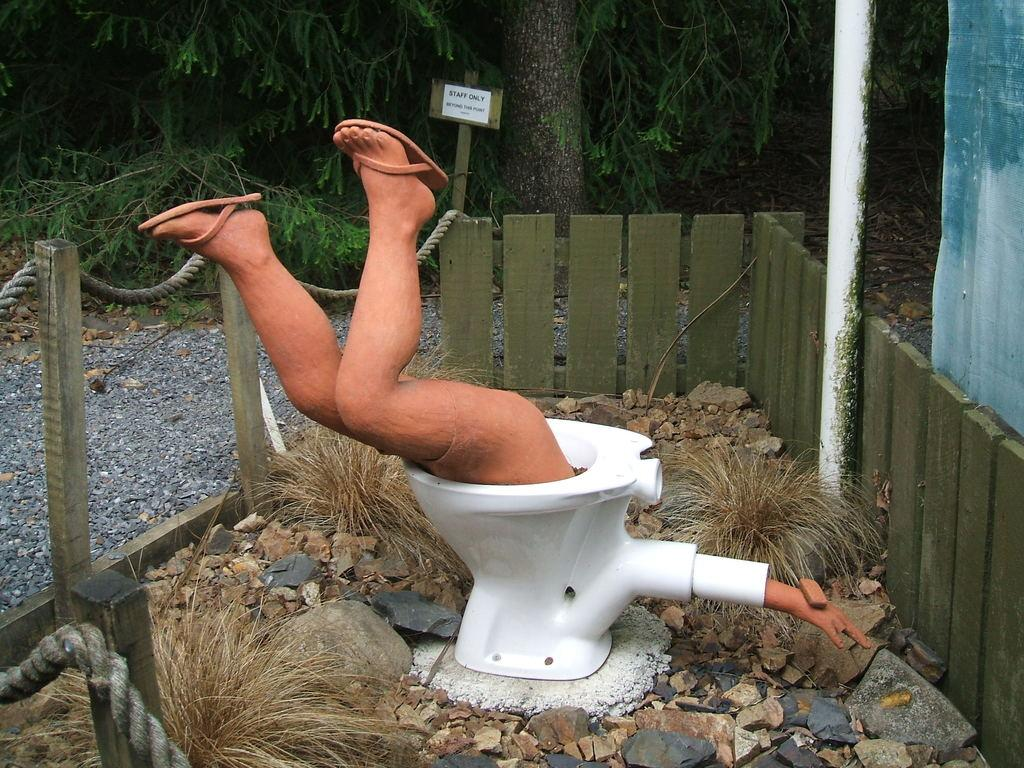What is the person in the image doing? There is a person inside the toilet in the image. What can be seen in the background of the image? There is a fence and trees with green leaves visible in the background of the image. Can you describe the object with a wooden stick in the image? There is a board attached to a wooden stick in the image. What type of rice is being cooked in the image? There is no rice present in the image. How does the pear contribute to the person's wealth in the image? There is no pear or mention of wealth in the image. 